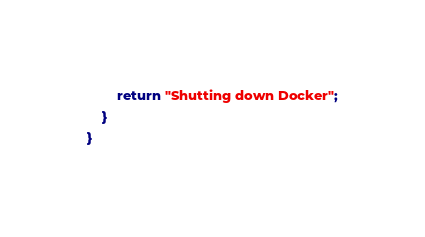<code> <loc_0><loc_0><loc_500><loc_500><_Java_>        return "Shutting down Docker";
    }
}
</code> 